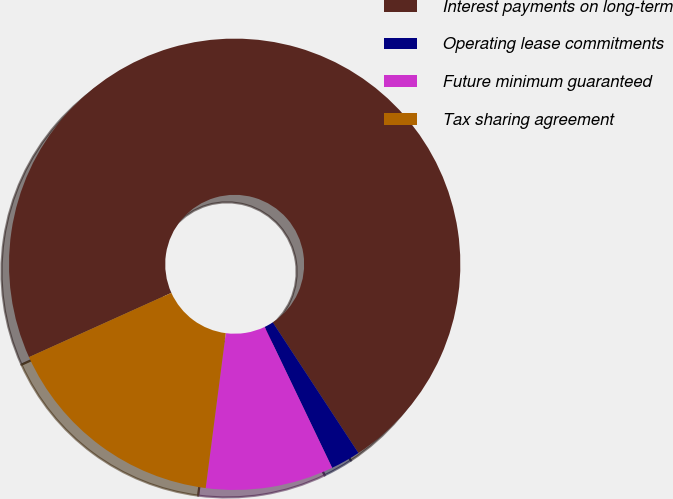<chart> <loc_0><loc_0><loc_500><loc_500><pie_chart><fcel>Interest payments on long-term<fcel>Operating lease commitments<fcel>Future minimum guaranteed<fcel>Tax sharing agreement<nl><fcel>72.51%<fcel>2.13%<fcel>9.16%<fcel>16.2%<nl></chart> 